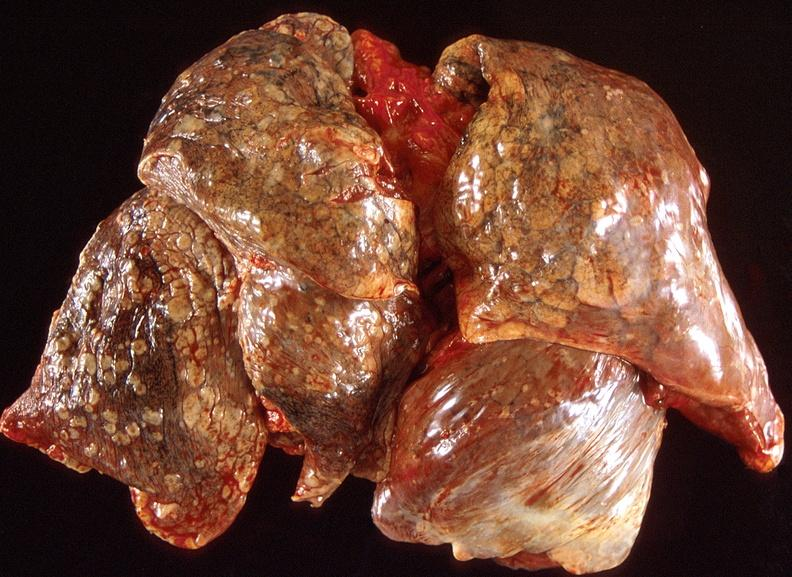what does this image show?
Answer the question using a single word or phrase. Lung carcinoma 